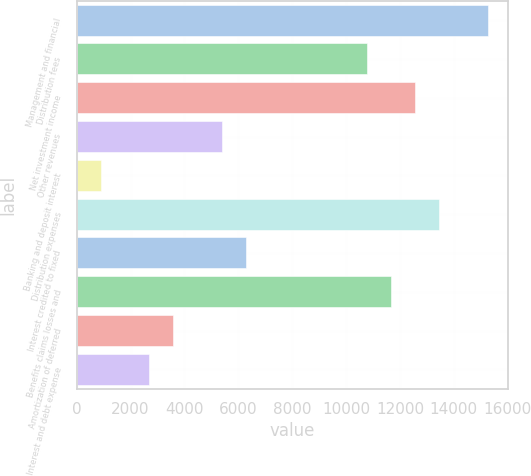Convert chart. <chart><loc_0><loc_0><loc_500><loc_500><bar_chart><fcel>Management and financial<fcel>Distribution fees<fcel>Net investment income<fcel>Other revenues<fcel>Banking and deposit interest<fcel>Distribution expenses<fcel>Interest credited to fixed<fcel>Benefits claims losses and<fcel>Amortization of deferred<fcel>Interest and debt expense<nl><fcel>15262.9<fcel>10774.4<fcel>12569.8<fcel>5388.2<fcel>899.7<fcel>13467.5<fcel>6285.9<fcel>11672.1<fcel>3592.8<fcel>2695.1<nl></chart> 